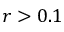<formula> <loc_0><loc_0><loc_500><loc_500>r > 0 . 1</formula> 